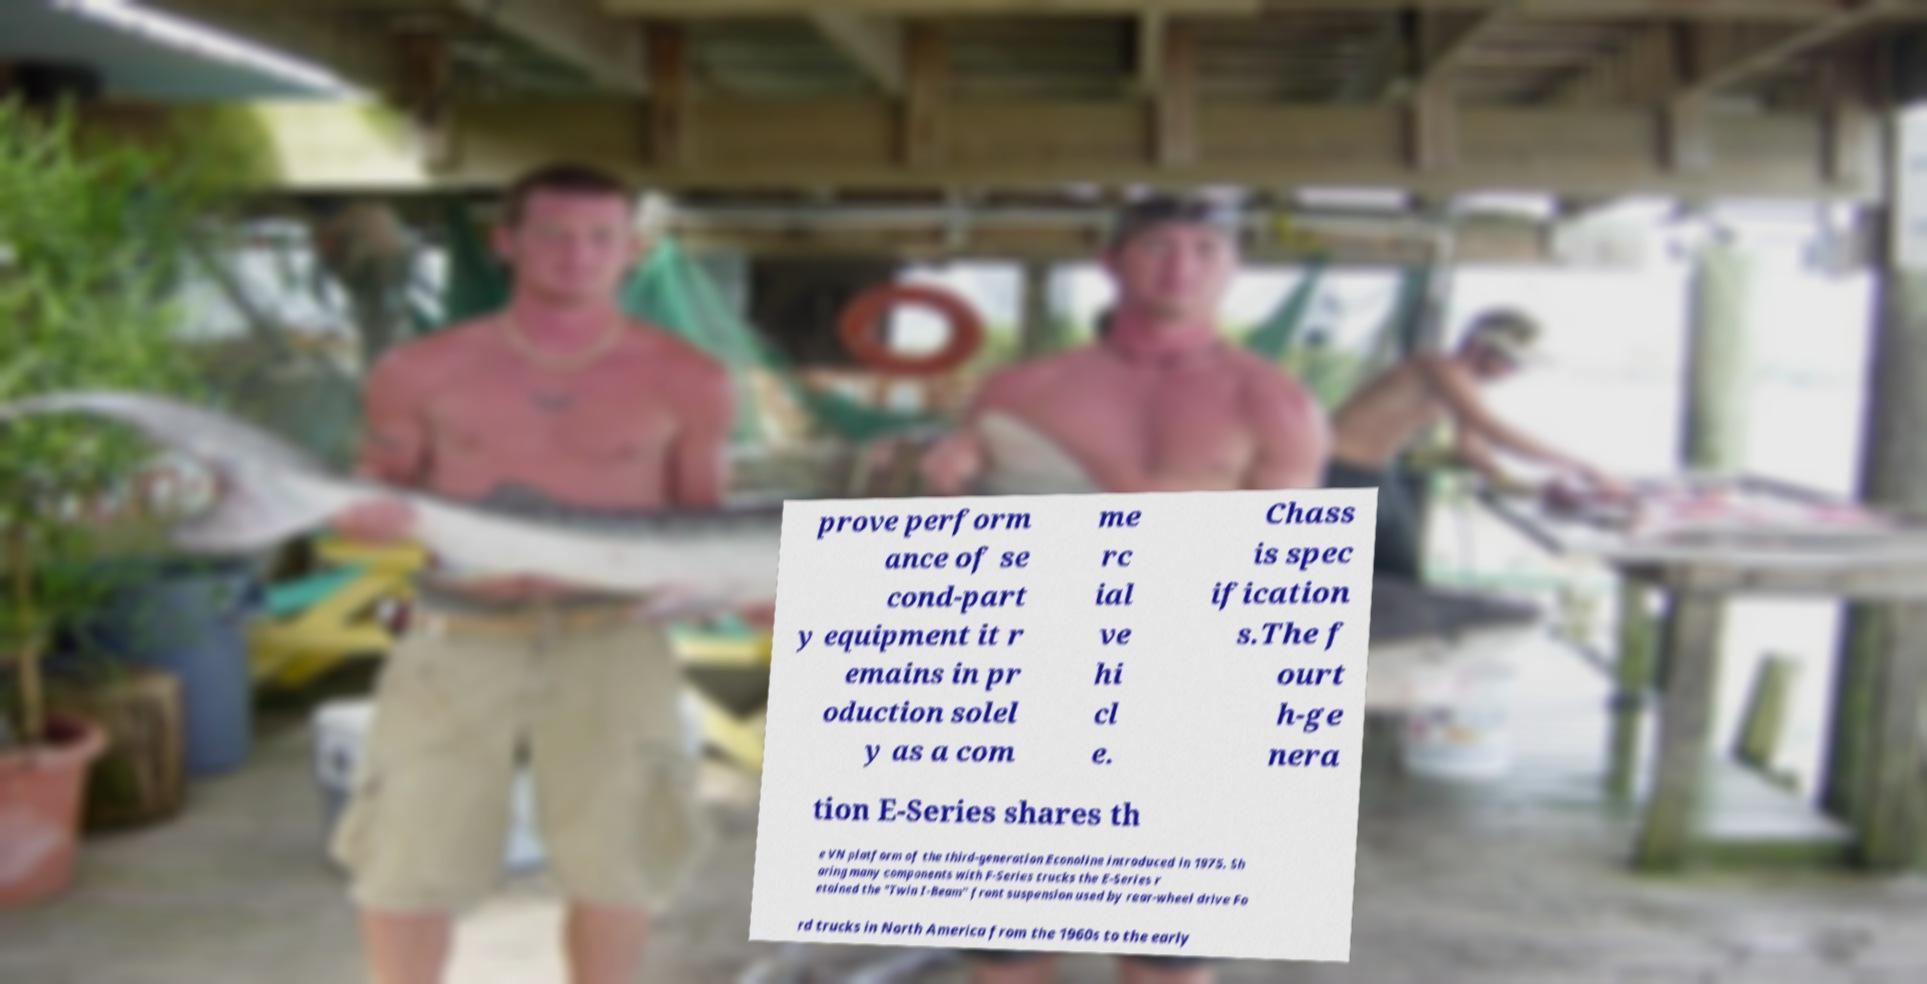Can you read and provide the text displayed in the image?This photo seems to have some interesting text. Can you extract and type it out for me? prove perform ance of se cond-part y equipment it r emains in pr oduction solel y as a com me rc ial ve hi cl e. Chass is spec ification s.The f ourt h-ge nera tion E-Series shares th e VN platform of the third-generation Econoline introduced in 1975. Sh aring many components with F-Series trucks the E-Series r etained the "Twin I-Beam" front suspension used by rear-wheel drive Fo rd trucks in North America from the 1960s to the early 